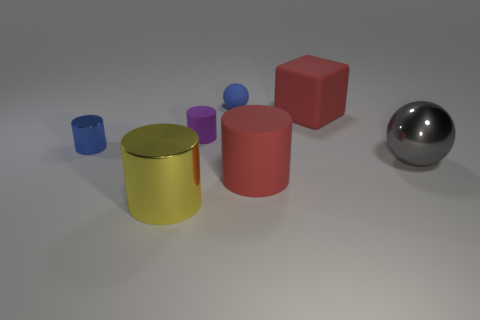Subtract all yellow metal cylinders. How many cylinders are left? 3 Add 1 red rubber cylinders. How many objects exist? 8 Subtract 1 cylinders. How many cylinders are left? 3 Subtract all purple cylinders. How many cylinders are left? 3 Subtract all blocks. How many objects are left? 6 Subtract all gray cylinders. Subtract all gray cubes. How many cylinders are left? 4 Subtract all large green spheres. Subtract all tiny metallic cylinders. How many objects are left? 6 Add 7 large yellow shiny cylinders. How many large yellow shiny cylinders are left? 8 Add 2 blue objects. How many blue objects exist? 4 Subtract 0 gray cubes. How many objects are left? 7 